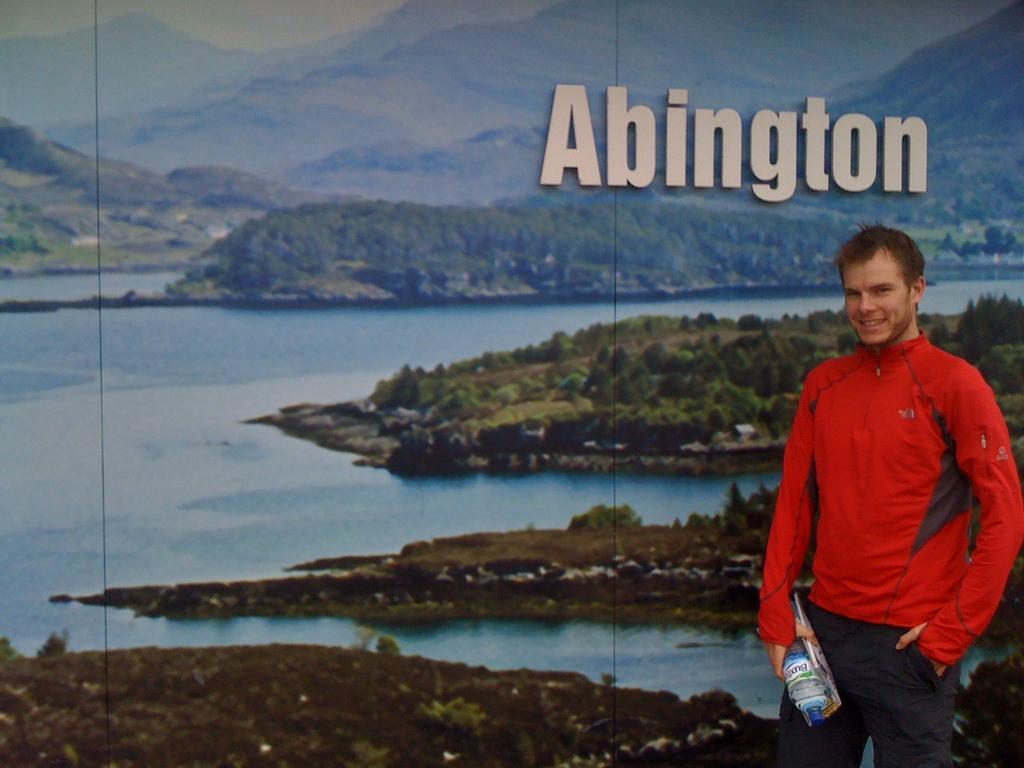Please provide a concise description of this image. This is an edited image, on the right side a man is standing, he wore a red color coat and trouser. behind him there is water, there are trees in this image. At the top there is a text in white color. 